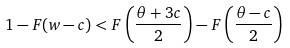Convert formula to latex. <formula><loc_0><loc_0><loc_500><loc_500>1 - F ( w - c ) < F \left ( \frac { \theta + 3 c } { 2 } \right ) - F \left ( \frac { \theta - c } { 2 } \right )</formula> 